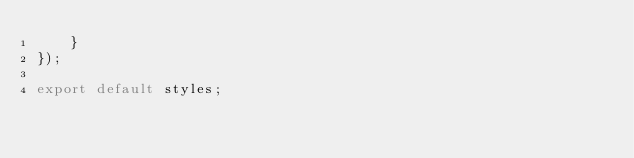<code> <loc_0><loc_0><loc_500><loc_500><_TypeScript_>    }
});

export default styles;</code> 